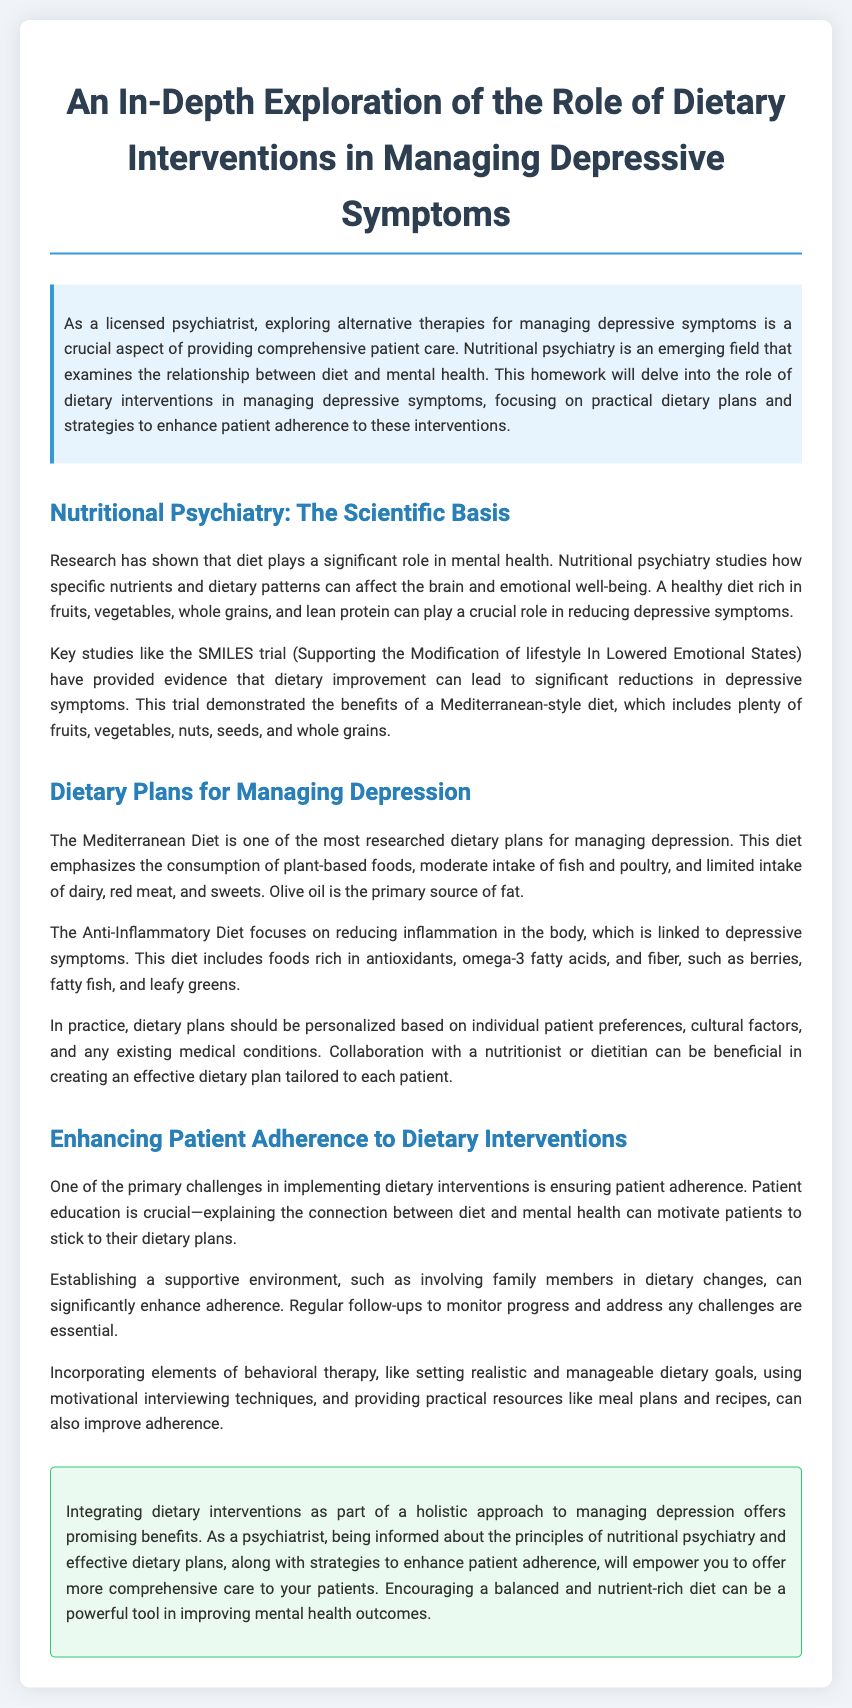What is the title of the homework? The title of the homework is presented at the top of the document.
Answer: An In-Depth Exploration of the Role of Dietary Interventions in Managing Depressive Symptoms What is one key study mentioned? The document references a specific study as evidence in the field of nutritional psychiatry.
Answer: SMILES trial What diet is emphasized for managing depression? The document explains various dietary interventions focusing on one specific diet.
Answer: Mediterranean Diet What are two dietary plans discussed? The homework describes two distinct dietary approaches for managing depressive symptoms.
Answer: Mediterranean Diet, Anti-Inflammatory Diet What is a crucial factor in enhancing patient adherence? The document highlights an essential strategy to improve adherence to dietary interventions.
Answer: Patient education How should dietary plans be tailored? The document suggests a personalized approach based on specifics about individual patients.
Answer: Individual patient preferences What is the primary source of fat in the Mediterranean Diet? The document specifies the main source of fat in this dietary plan.
Answer: Olive oil What is a method to improve dietary adherence? The homework outlines an effective technique that can help increase adherence to dietary changes.
Answer: Motivational interviewing techniques 